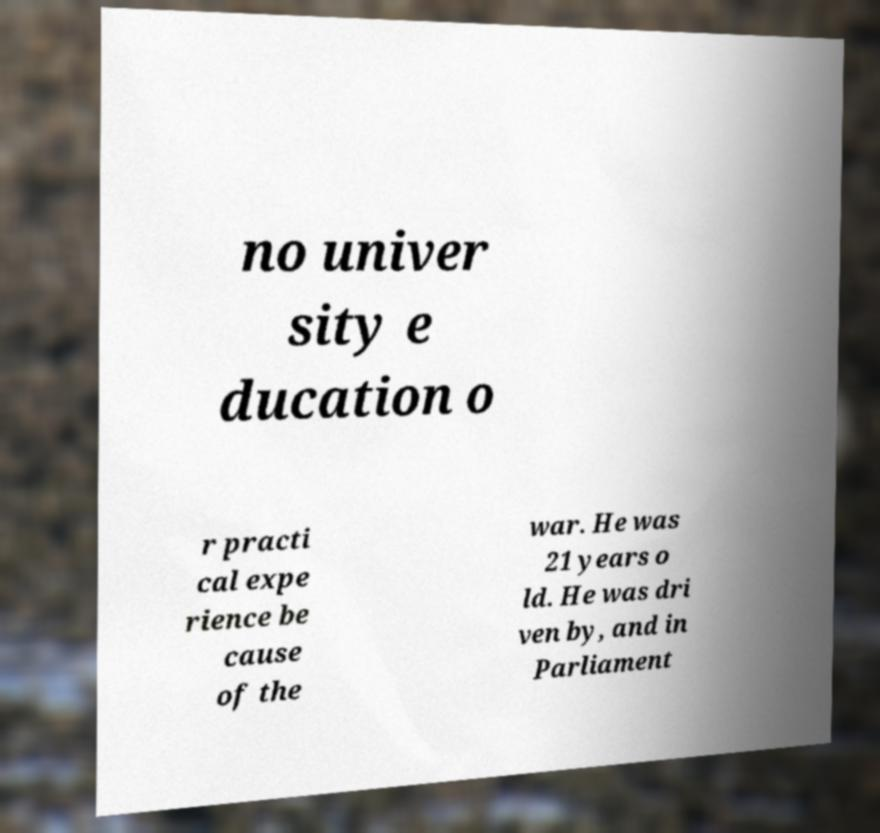Can you read and provide the text displayed in the image?This photo seems to have some interesting text. Can you extract and type it out for me? no univer sity e ducation o r practi cal expe rience be cause of the war. He was 21 years o ld. He was dri ven by, and in Parliament 